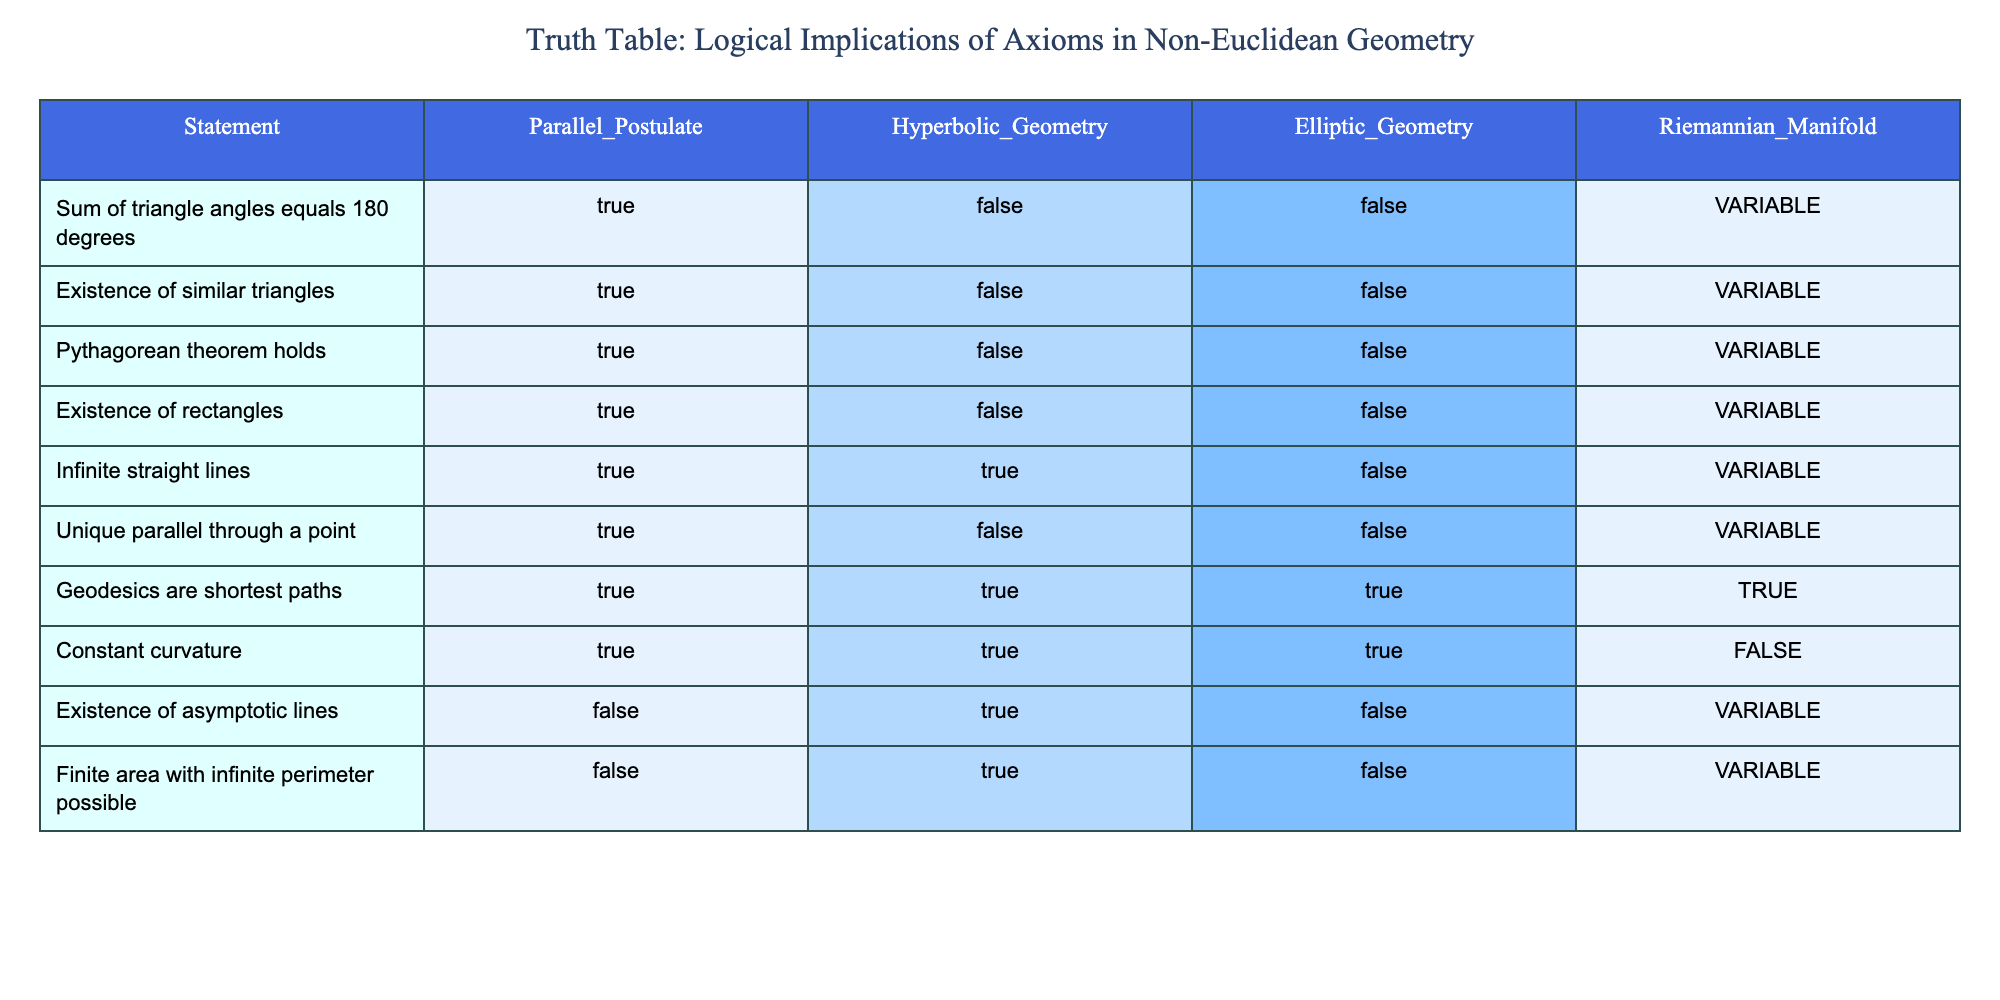What is the truth value of the statement "Sum of triangle angles equals 180 degrees" in Hyperbolic Geometry? The table shows the values under the Hyperbolic Geometry column for the statement "Sum of triangle angles equals 180 degrees." The value listed is FALSE.
Answer: FALSE Does the Pythagorean theorem hold in Elliptic Geometry? According to the table, under the Elliptic Geometry column for the statement "Pythagorean theorem holds," the value is FALSE.
Answer: FALSE How many geometries allow for the existence of rectangles? The table indicates that rectangles are allowed under the Parallel Postulate, but FALSE under Hyperbolic and Elliptic Geometry. Hence, only one geometry (Euclidean) allows for rectangles.
Answer: 1 Is there a unique parallel line through a point in Hyperbolic Geometry? Checking the Hyperbolic Geometry column for "Unique parallel through a point," we see the value is FALSE. Thus, there is no unique parallel line through a point in Hyperbolic Geometry.
Answer: FALSE In how many geometries do geodesics serve as the shortest paths? The table shows that geodesics are shortest paths in all four categories: True for Parallel Postulate, Hyperbolic, Elliptic Geometry, and Riemannian Manifold. Therefore, geodesics serve as shortest paths in four geometries.
Answer: 4 If we take the existence of asymptotic lines statement, how many geometries affirm its existence? Referring to the column for "Existence of asymptotic lines", the table shows it is FALSE under the Parallel Postulate and Elliptic Geometry, but TRUE under Hyperbolic Geometry (shown as VARIABLE). Thus, only one geometry (Hyperbolic) affirms asymptotic lines exist.
Answer: 1 What is the relationship between infinite straight lines and Hyperbolic Geometry? The table indicates that under the statement "Infinite straight lines," Hyperbolic Geometry is TRUE, meaning this geometric framework allows for infinite straight lines.
Answer: TRUE What is the sum of the truth values for the Existence of similar triangles across all geometries? The values are TRUE in Euclidean (Parallel Postulate) and FALSE in Hyperbolic and Elliptic, and VARIABLE in Riemannian Manifold. Assuming TRUE=1, FALSE=0, and VARIABLE as undetermined (0.5), the sum is 1 (TRUE) + 0 (FALSE) + 0 (FALSE) + 0.5 (VARIABLE) = 1.5.
Answer: 1.5 Are there any geometries where the Constant curvature statement holds as FALSE? The Constant curvature statement is FALSE only under Riemannian Manifold according to the table. So, yes, there is one geometry (Riemannian Manifold) where this statement is FALSE.
Answer: YES 